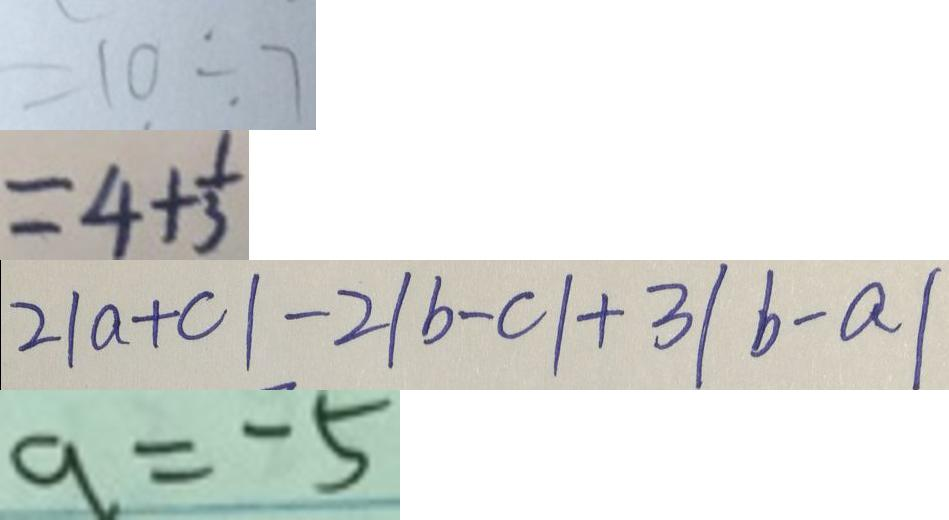Convert formula to latex. <formula><loc_0><loc_0><loc_500><loc_500>= 1 0 \div 7 
 = 4 + \frac { 1 } { 3 } 
 2 \vert a + c \vert - 2 \vert b - c \vert + 3 \vert b - a \vert 
 a = - 5</formula> 